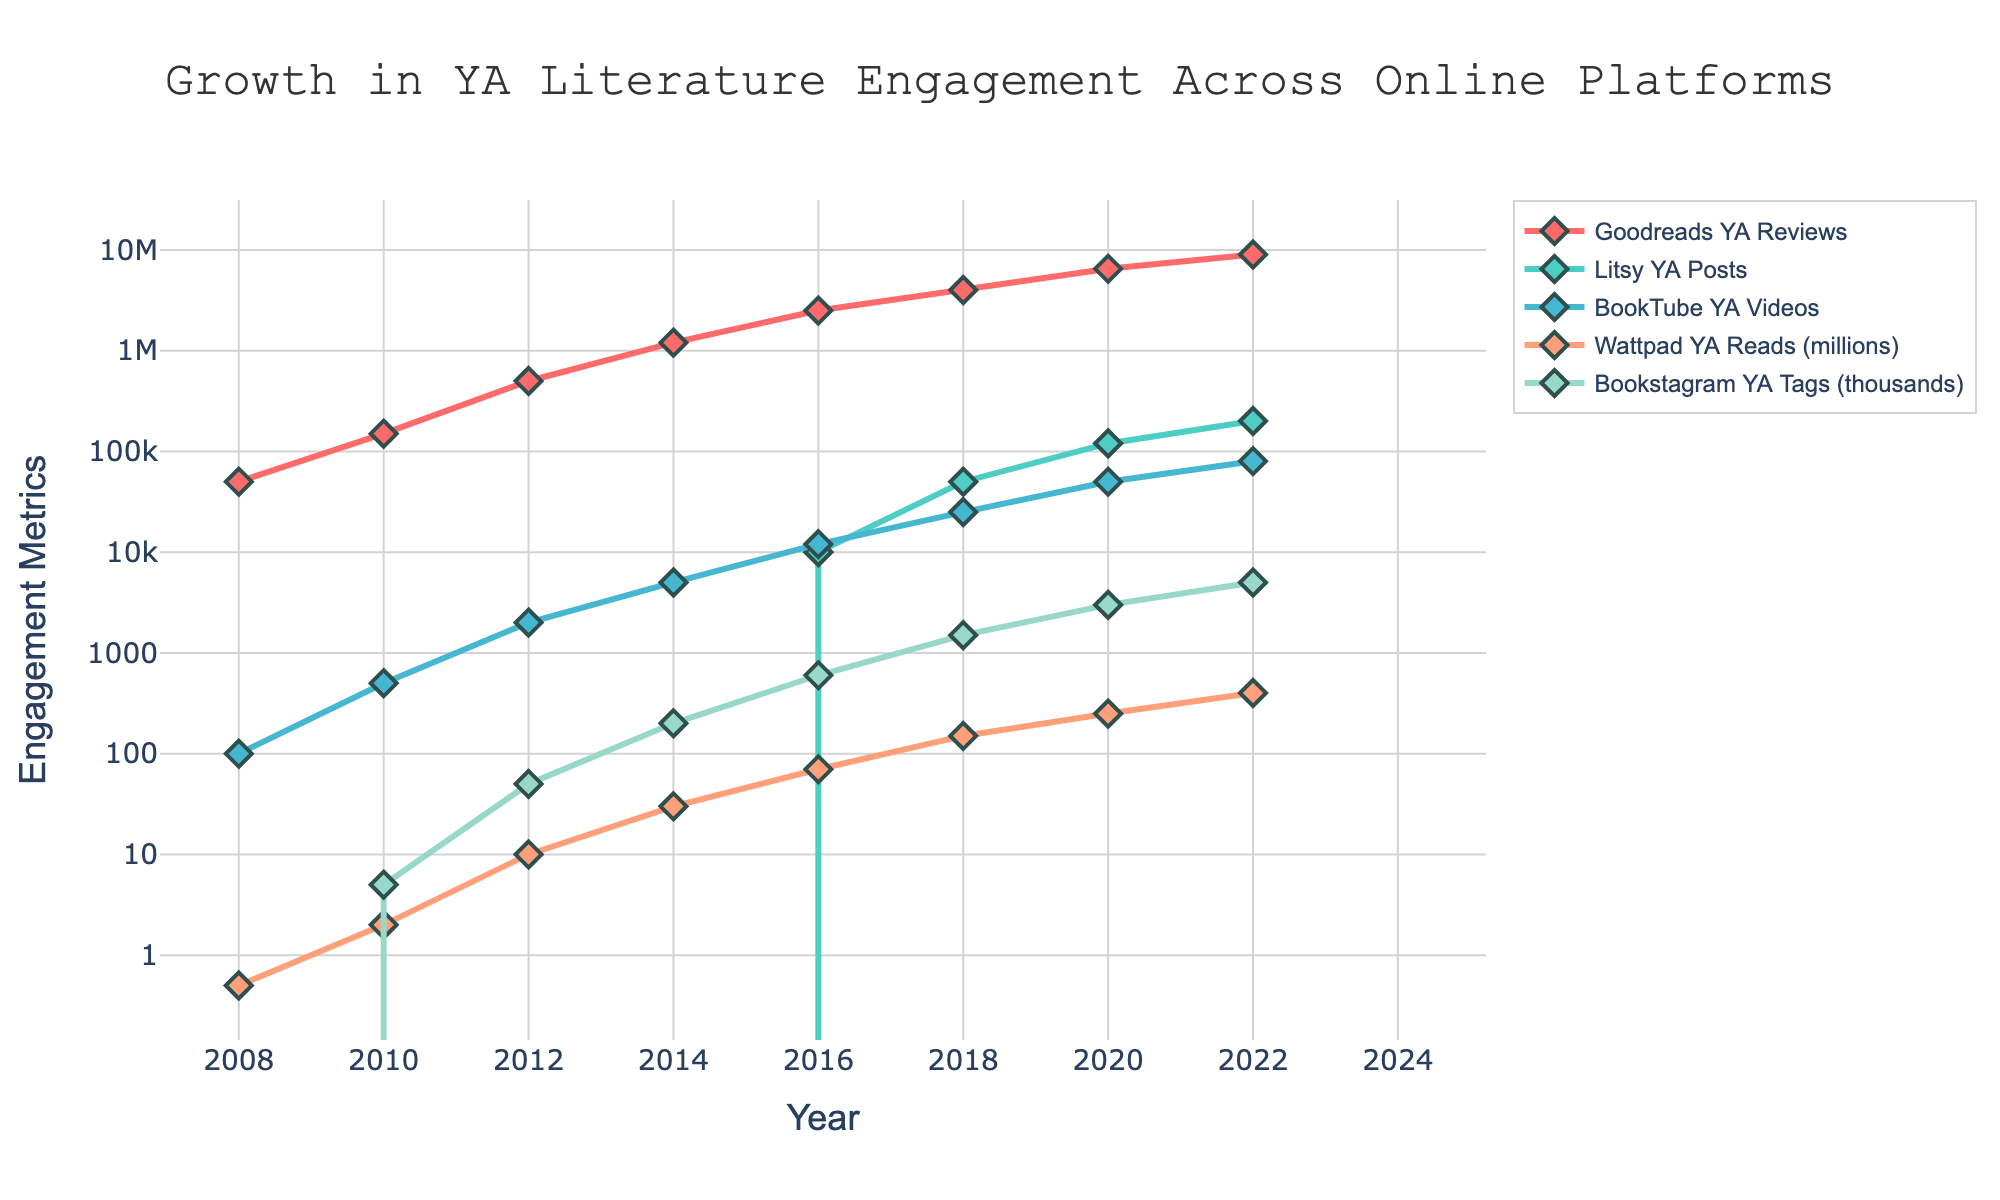Which platform had the highest engagement in 2022? To find the platform with the highest engagement in 2022, look at the end of each line on the graph. The line representing "Goodreads YA Reviews" reaches the highest point, indicating it had the highest engagement.
Answer: Goodreads YA Reviews How many years did it take for Wattpad YA Reads to reach 400 million reads? Identify the year Wattpad YA Reads first reached 400 million reads, which is 2022, and subtract the starting year when it had 0.5 million reads, which is 2008. The difference is 2022 - 2008.
Answer: 14 years Which platform showed the most significant growth between 2010 and 2014? Compare the slopes of each line segment between the years 2010 and 2014. "Goodreads YA Reviews" shows the steepest increase among all the platforms during this period.
Answer: Goodreads YA Reviews What is the total engagement for BookTube YA Videos in 2018 and 2020 combined? From the graph, find the values for BookTube YA Videos in 2018 and 2020, which are 25,000 and 50,000 respectively. Add these values together: 25,000 + 50,000.
Answer: 75,000 Which platform had the least amount of engagement consistently until 2016? By examining the graph, determine the platform with the lowest engagement levels up until 2016. "Litsy YA Posts" appears to remain at a very low or zero level until 2016.
Answer: Litsy YA Posts By how much did Bookstagram YA Tags increase from 2016 to 2020? Check the value of Bookstagram YA Tags in 2016 and 2020 from the graph, which are 600 and 3,000 respectively. Subtract the 2016 value from the 2020 value: 3,000 - 600.
Answer: 2,400 What is the average engagement for Goodreads YA Reviews in 2008, 2010, 2012, and 2014? Take the values of Goodreads YA Reviews for the years 2008 (50,000), 2010 (150,000), 2012 (500,000), and 2014 (1,200,000). Sum these values and then divide by the number of years: (50,000 + 150,000 + 500,000 + 1,200,000) / 4.
Answer: 475,000 Which platform showed the highest increase in engagement metrics between 2016 and 2022? Compare the increase in engagement metrics of all platforms between 2016 and 2022 by checking the start and end points in this period. "Goodreads YA Reviews" increased from 2,500,000 in 2016 to 9,000,000 in 2022. This is an increase of 6,500,000, which is the highest among the platforms.
Answer: Goodreads YA Reviews 